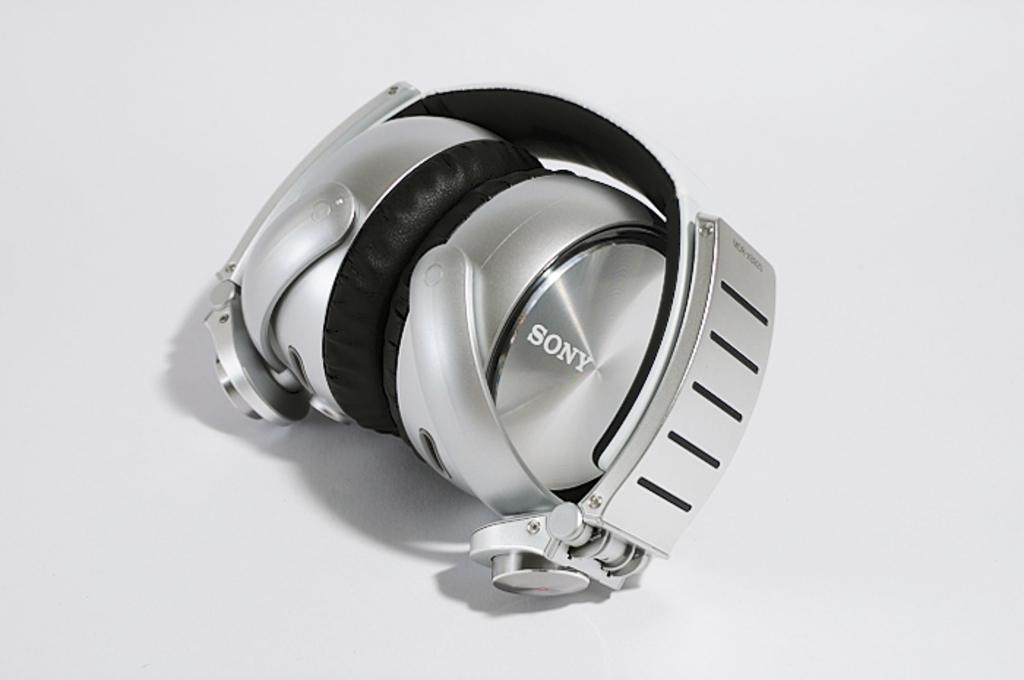Provide a one-sentence caption for the provided image. Silver headphones which say SONY on the front. 